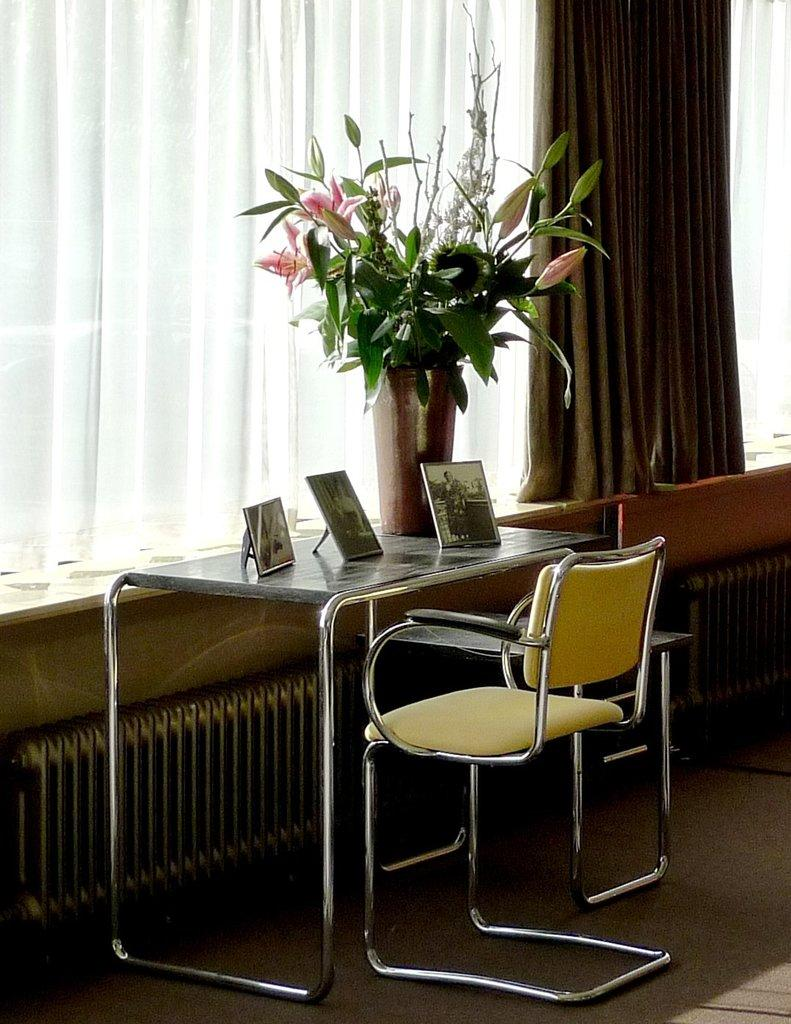What material is present in the image? There is cloth in the image. What type of furniture is visible in the image? There is a table and chairs on the floor in the image. What is placed on the table in the image? There is a flower vase and photos on the table in the image. What is the color of the background in the image? The background of the image is white. What type of wall is visible in the image? There is no wall visible in the image; the background is white. How is the cloth being used for division in the image? The cloth is not being used for division in the image; it is simply present as a material. 